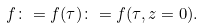<formula> <loc_0><loc_0><loc_500><loc_500>f \colon = f ( \tau ) \colon = f ( \tau , z = 0 ) .</formula> 